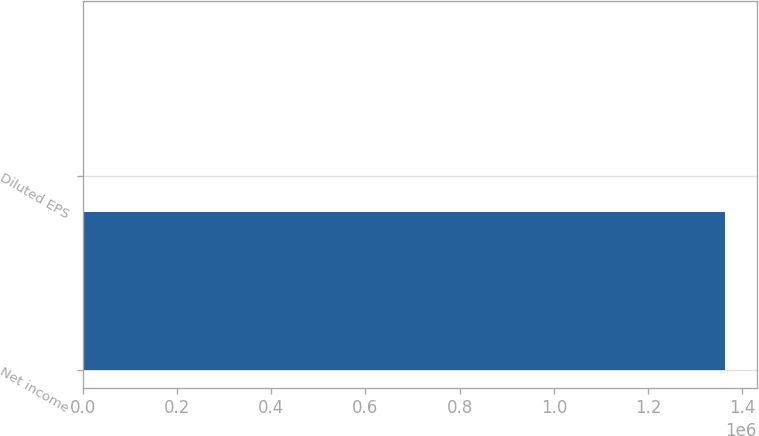<chart> <loc_0><loc_0><loc_500><loc_500><bar_chart><fcel>Net income<fcel>Diluted EPS<nl><fcel>1.36301e+06<fcel>3.65<nl></chart> 